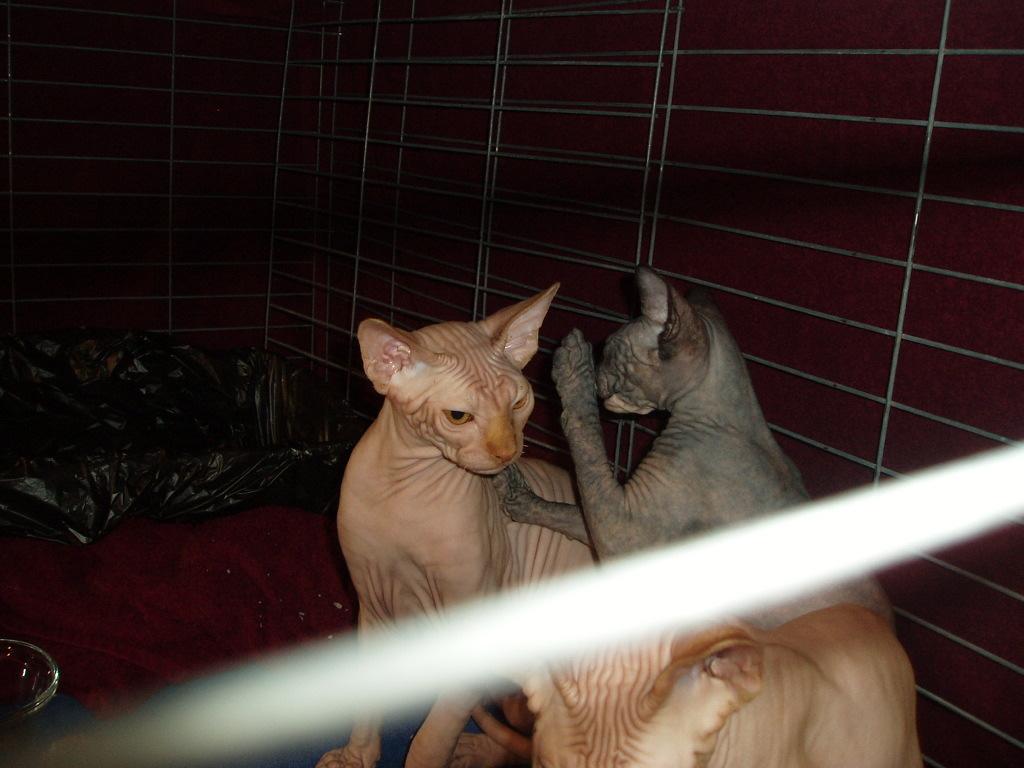In one or two sentences, can you explain what this image depicts? In this picture we can see two cats, in the background there is wall, we can see a cover on the left side. 